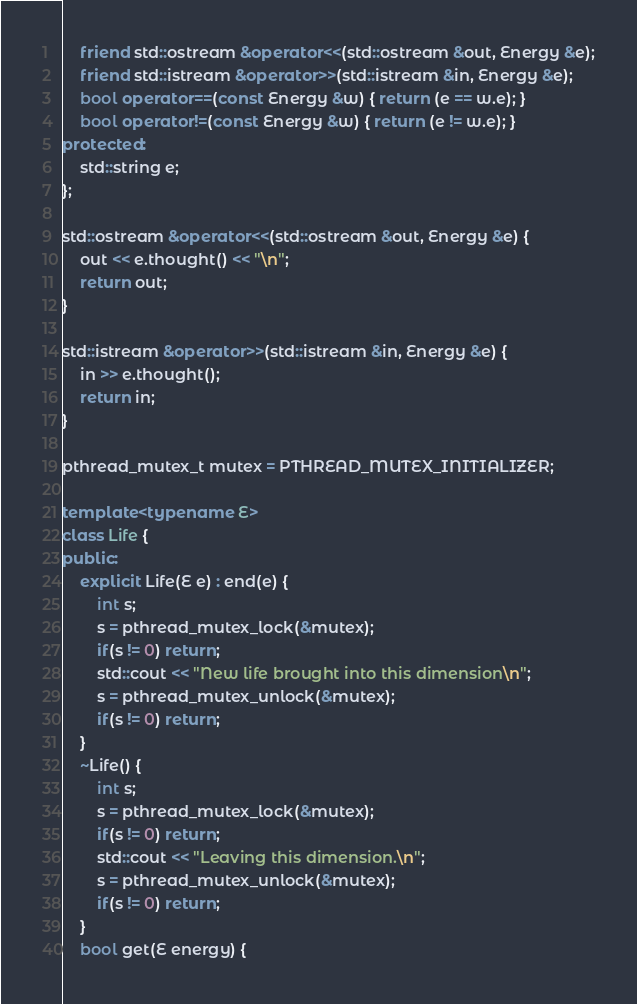<code> <loc_0><loc_0><loc_500><loc_500><_C++_>    friend std::ostream &operator<<(std::ostream &out, Energy &e);
    friend std::istream &operator>>(std::istream &in, Energy &e);
    bool operator==(const Energy &w) { return (e == w.e); }
    bool operator!=(const Energy &w) { return (e != w.e); }
protected:
    std::string e;
};

std::ostream &operator<<(std::ostream &out, Energy &e) {
    out << e.thought() << "\n";
    return out;
}

std::istream &operator>>(std::istream &in, Energy &e) {
    in >> e.thought();
    return in;
}

pthread_mutex_t mutex = PTHREAD_MUTEX_INITIALIZER;

template<typename E>
class Life {
public:
    explicit Life(E e) : end(e) {
        int s;
        s = pthread_mutex_lock(&mutex);
        if(s != 0) return;
        std::cout << "New life brought into this dimension\n";
        s = pthread_mutex_unlock(&mutex);
        if(s != 0) return;
    }
    ~Life() {
        int s;
        s = pthread_mutex_lock(&mutex);
        if(s != 0) return;
        std::cout << "Leaving this dimension.\n";
        s = pthread_mutex_unlock(&mutex);
        if(s != 0) return;
    }
    bool get(E energy) {</code> 